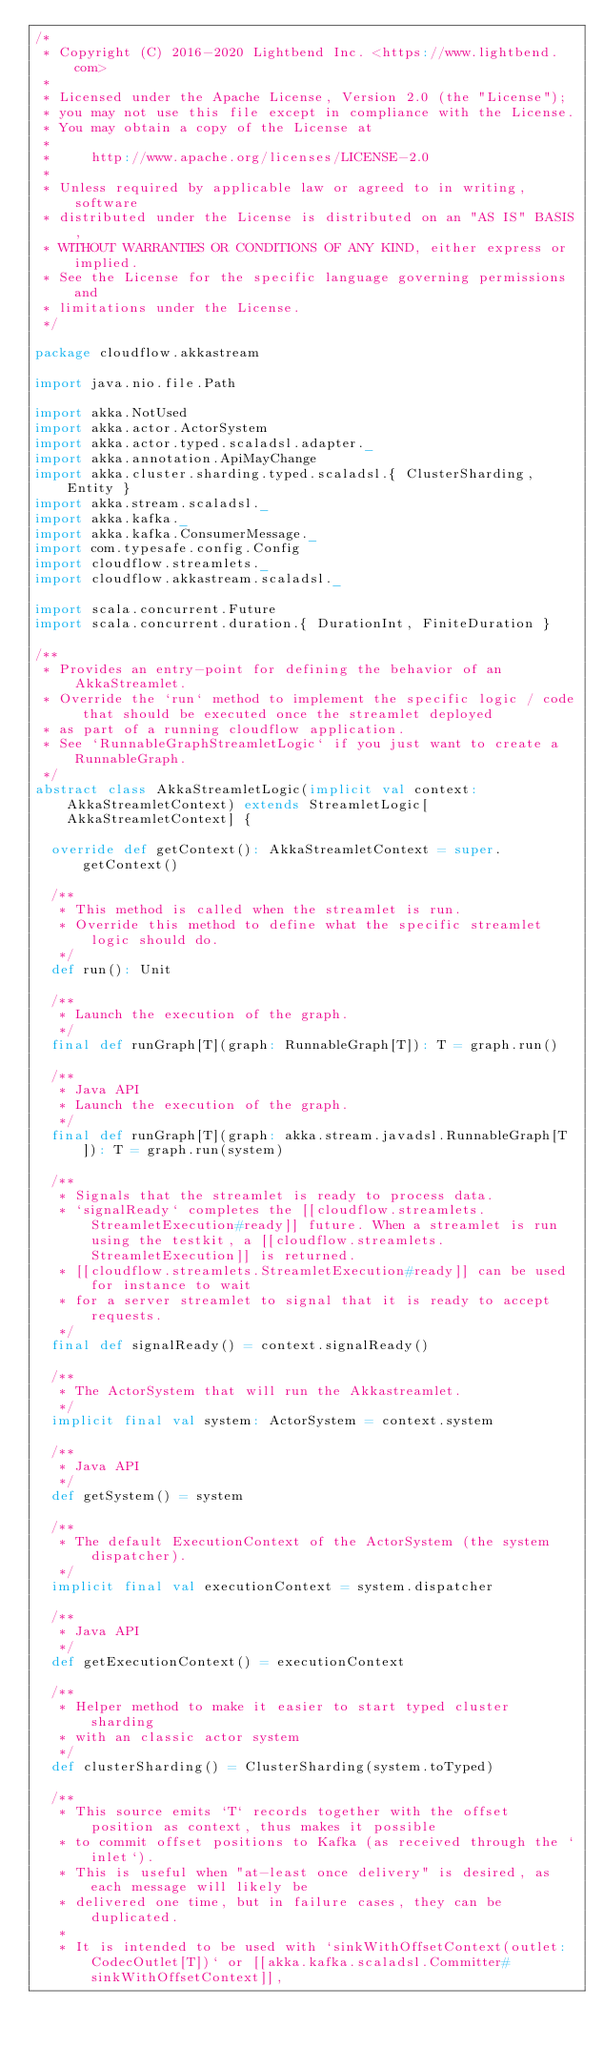<code> <loc_0><loc_0><loc_500><loc_500><_Scala_>/*
 * Copyright (C) 2016-2020 Lightbend Inc. <https://www.lightbend.com>
 *
 * Licensed under the Apache License, Version 2.0 (the "License");
 * you may not use this file except in compliance with the License.
 * You may obtain a copy of the License at
 *
 *     http://www.apache.org/licenses/LICENSE-2.0
 *
 * Unless required by applicable law or agreed to in writing, software
 * distributed under the License is distributed on an "AS IS" BASIS,
 * WITHOUT WARRANTIES OR CONDITIONS OF ANY KIND, either express or implied.
 * See the License for the specific language governing permissions and
 * limitations under the License.
 */

package cloudflow.akkastream

import java.nio.file.Path

import akka.NotUsed
import akka.actor.ActorSystem
import akka.actor.typed.scaladsl.adapter._
import akka.annotation.ApiMayChange
import akka.cluster.sharding.typed.scaladsl.{ ClusterSharding, Entity }
import akka.stream.scaladsl._
import akka.kafka._
import akka.kafka.ConsumerMessage._
import com.typesafe.config.Config
import cloudflow.streamlets._
import cloudflow.akkastream.scaladsl._

import scala.concurrent.Future
import scala.concurrent.duration.{ DurationInt, FiniteDuration }

/**
 * Provides an entry-point for defining the behavior of an AkkaStreamlet.
 * Override the `run` method to implement the specific logic / code that should be executed once the streamlet deployed
 * as part of a running cloudflow application.
 * See `RunnableGraphStreamletLogic` if you just want to create a RunnableGraph.
 */
abstract class AkkaStreamletLogic(implicit val context: AkkaStreamletContext) extends StreamletLogic[AkkaStreamletContext] {

  override def getContext(): AkkaStreamletContext = super.getContext()

  /**
   * This method is called when the streamlet is run.
   * Override this method to define what the specific streamlet logic should do.
   */
  def run(): Unit

  /**
   * Launch the execution of the graph.
   */
  final def runGraph[T](graph: RunnableGraph[T]): T = graph.run()

  /**
   * Java API
   * Launch the execution of the graph.
   */
  final def runGraph[T](graph: akka.stream.javadsl.RunnableGraph[T]): T = graph.run(system)

  /**
   * Signals that the streamlet is ready to process data.
   * `signalReady` completes the [[cloudflow.streamlets.StreamletExecution#ready]] future. When a streamlet is run using the testkit, a [[cloudflow.streamlets.StreamletExecution]] is returned.
   * [[cloudflow.streamlets.StreamletExecution#ready]] can be used for instance to wait
   * for a server streamlet to signal that it is ready to accept requests.
   */
  final def signalReady() = context.signalReady()

  /**
   * The ActorSystem that will run the Akkastreamlet.
   */
  implicit final val system: ActorSystem = context.system

  /**
   * Java API
   */
  def getSystem() = system

  /**
   * The default ExecutionContext of the ActorSystem (the system dispatcher).
   */
  implicit final val executionContext = system.dispatcher

  /**
   * Java API
   */
  def getExecutionContext() = executionContext

  /**
   * Helper method to make it easier to start typed cluster sharding
   * with an classic actor system
   */
  def clusterSharding() = ClusterSharding(system.toTyped)

  /**
   * This source emits `T` records together with the offset position as context, thus makes it possible
   * to commit offset positions to Kafka (as received through the `inlet`).
   * This is useful when "at-least once delivery" is desired, as each message will likely be
   * delivered one time, but in failure cases, they can be duplicated.
   *
   * It is intended to be used with `sinkWithOffsetContext(outlet: CodecOutlet[T])` or [[akka.kafka.scaladsl.Committer#sinkWithOffsetContext]],</code> 